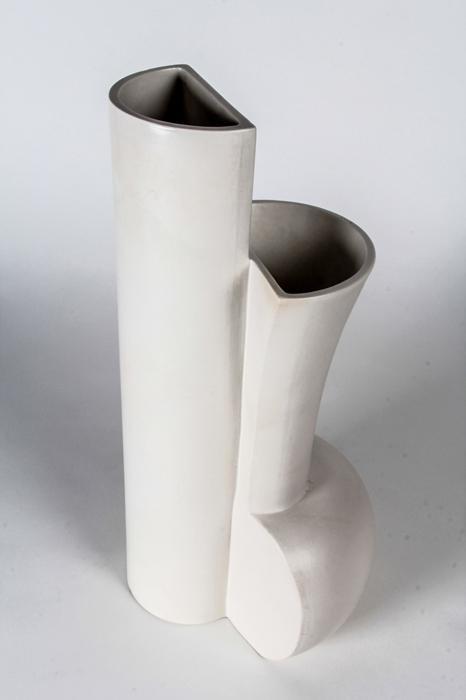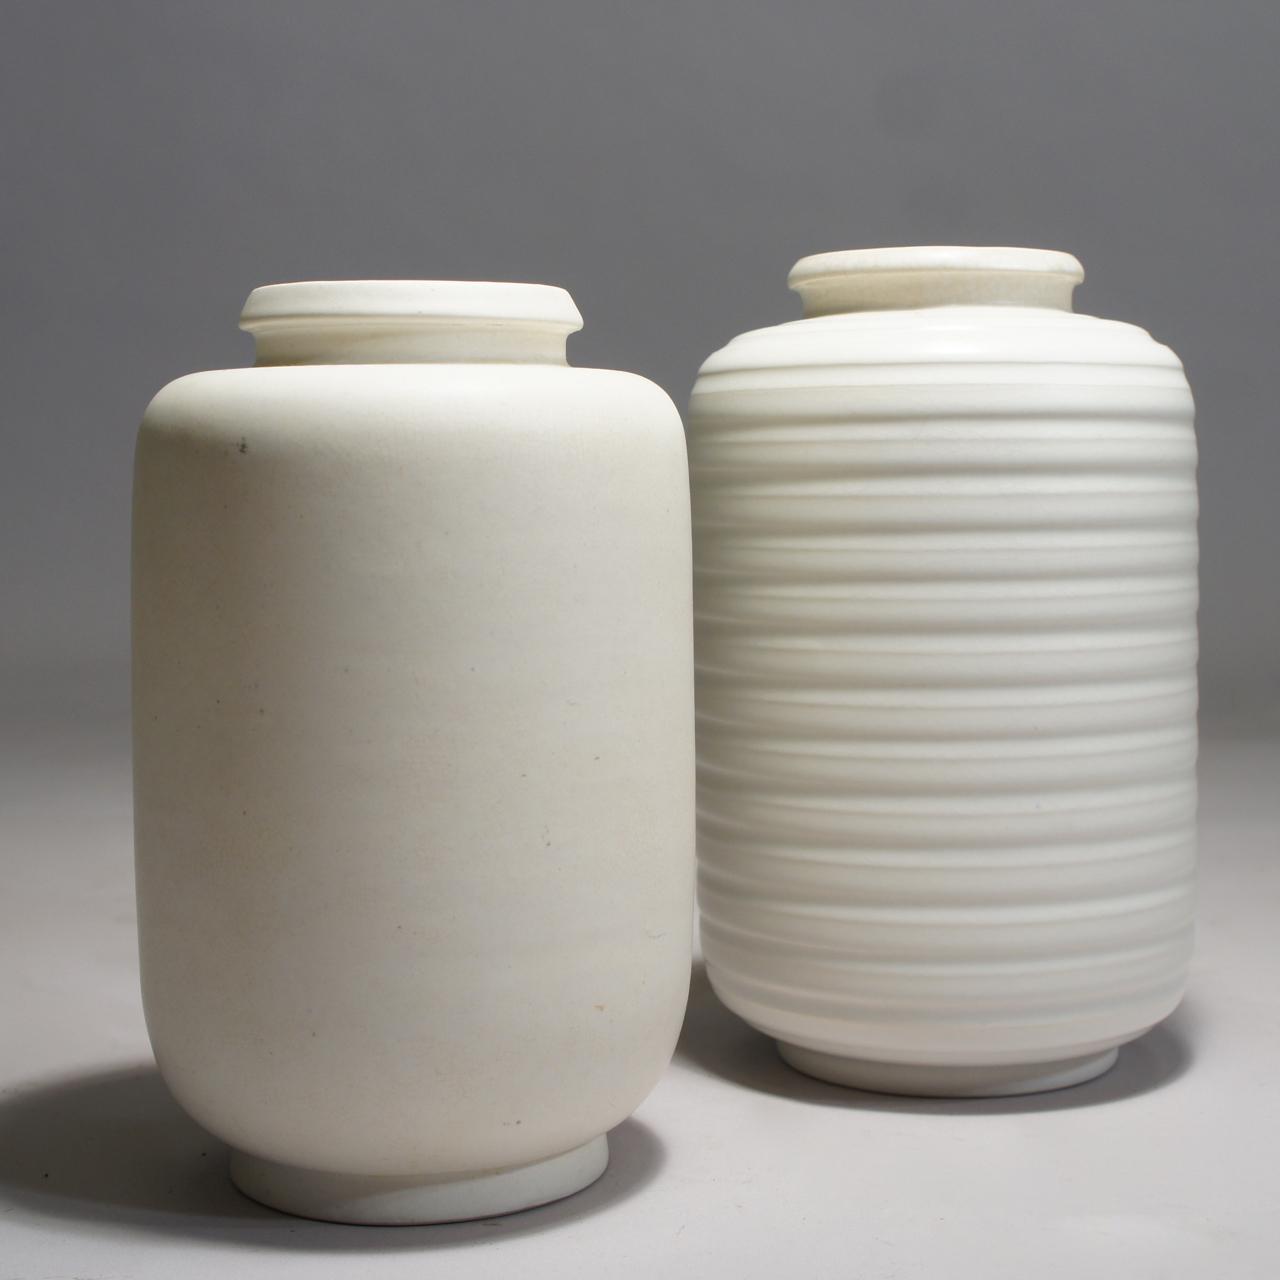The first image is the image on the left, the second image is the image on the right. Considering the images on both sides, is "One image has two vases of equal height." valid? Answer yes or no. Yes. 